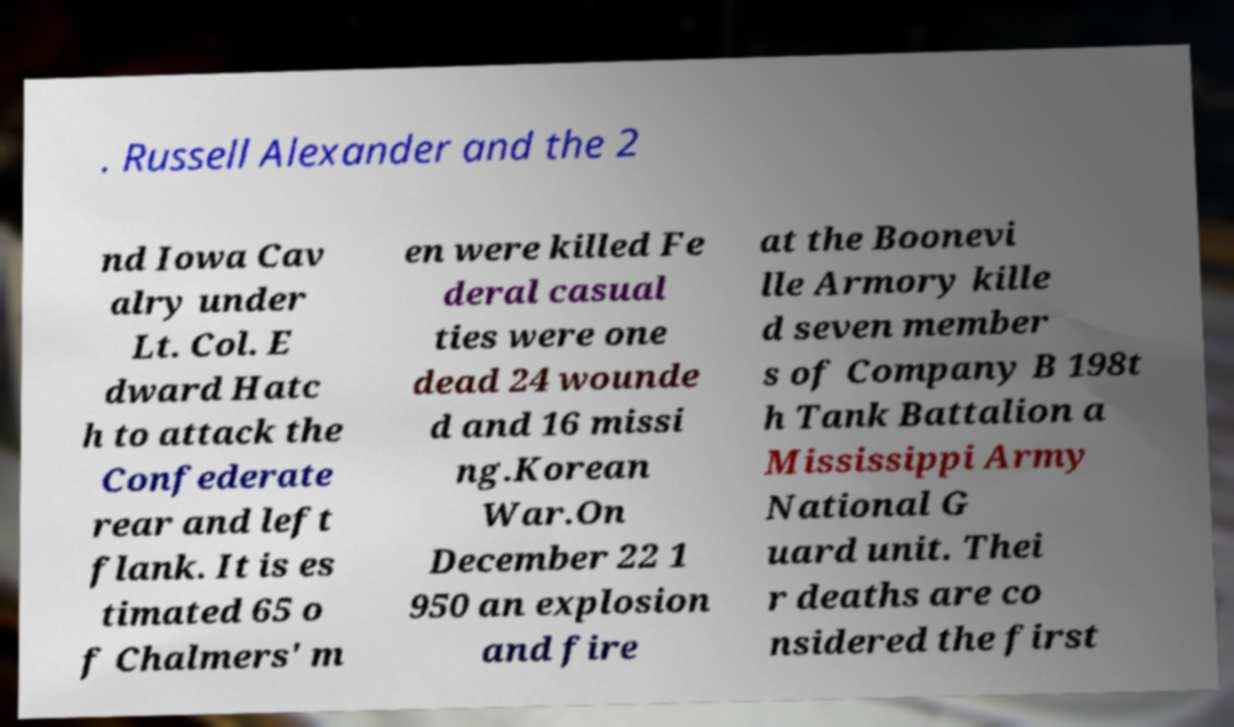Can you accurately transcribe the text from the provided image for me? . Russell Alexander and the 2 nd Iowa Cav alry under Lt. Col. E dward Hatc h to attack the Confederate rear and left flank. It is es timated 65 o f Chalmers' m en were killed Fe deral casual ties were one dead 24 wounde d and 16 missi ng.Korean War.On December 22 1 950 an explosion and fire at the Boonevi lle Armory kille d seven member s of Company B 198t h Tank Battalion a Mississippi Army National G uard unit. Thei r deaths are co nsidered the first 